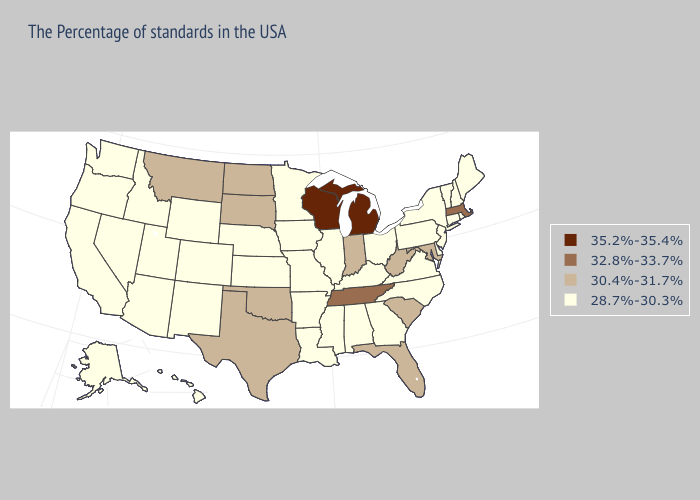Does Hawaii have the highest value in the USA?
Answer briefly. No. Does Ohio have a higher value than Idaho?
Keep it brief. No. What is the lowest value in the Northeast?
Quick response, please. 28.7%-30.3%. Among the states that border Wisconsin , which have the highest value?
Answer briefly. Michigan. What is the value of Missouri?
Answer briefly. 28.7%-30.3%. Among the states that border North Carolina , does Tennessee have the lowest value?
Give a very brief answer. No. What is the lowest value in the USA?
Keep it brief. 28.7%-30.3%. Does Ohio have the highest value in the MidWest?
Quick response, please. No. Name the states that have a value in the range 35.2%-35.4%?
Write a very short answer. Michigan, Wisconsin. Does Louisiana have a lower value than South Dakota?
Concise answer only. Yes. What is the highest value in the USA?
Give a very brief answer. 35.2%-35.4%. Name the states that have a value in the range 35.2%-35.4%?
Keep it brief. Michigan, Wisconsin. Which states have the highest value in the USA?
Short answer required. Michigan, Wisconsin. What is the lowest value in the USA?
Keep it brief. 28.7%-30.3%. How many symbols are there in the legend?
Give a very brief answer. 4. 